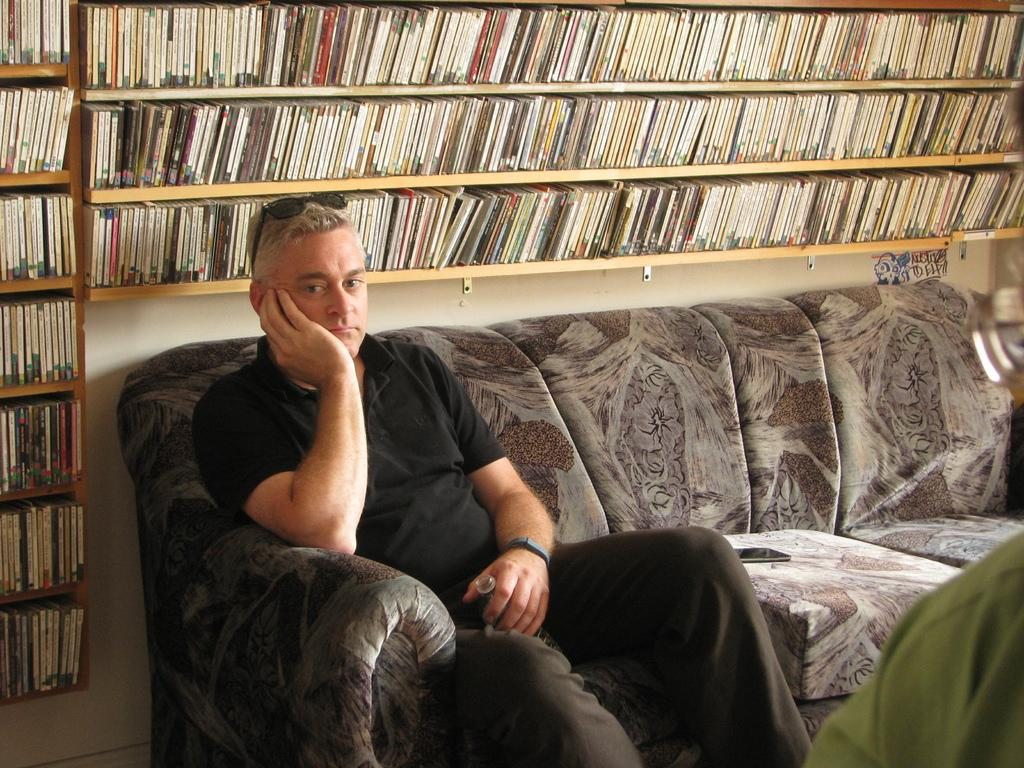What type of furniture is in the image? There is a sofa in the image. Who is sitting on the sofa? A: A man is sitting on the sofa. What is the man holding in his hand? The man is holding a bottle in his hand. What can be seen in the background of the image? There is a shelf in the background of the image. What is on the shelf? There are books on the shelf. What type of amusement is the man participating in while sitting on the sofa? There is no indication of any amusement in the image; the man is simply sitting on the sofa holding a bottle. 